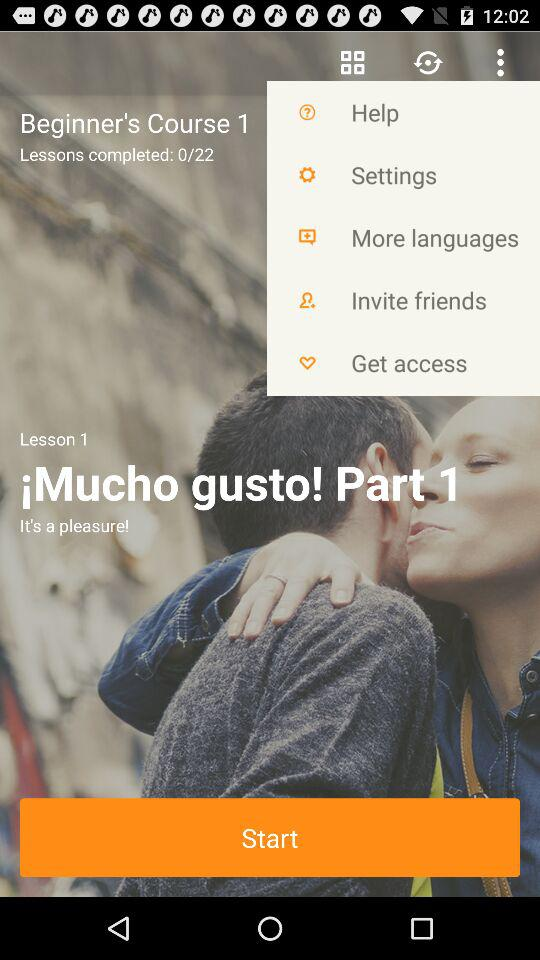At what lesson are we right now? You are at lesson 1 right now. 